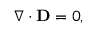Convert formula to latex. <formula><loc_0><loc_0><loc_500><loc_500>\nabla \cdot D = 0 ,</formula> 